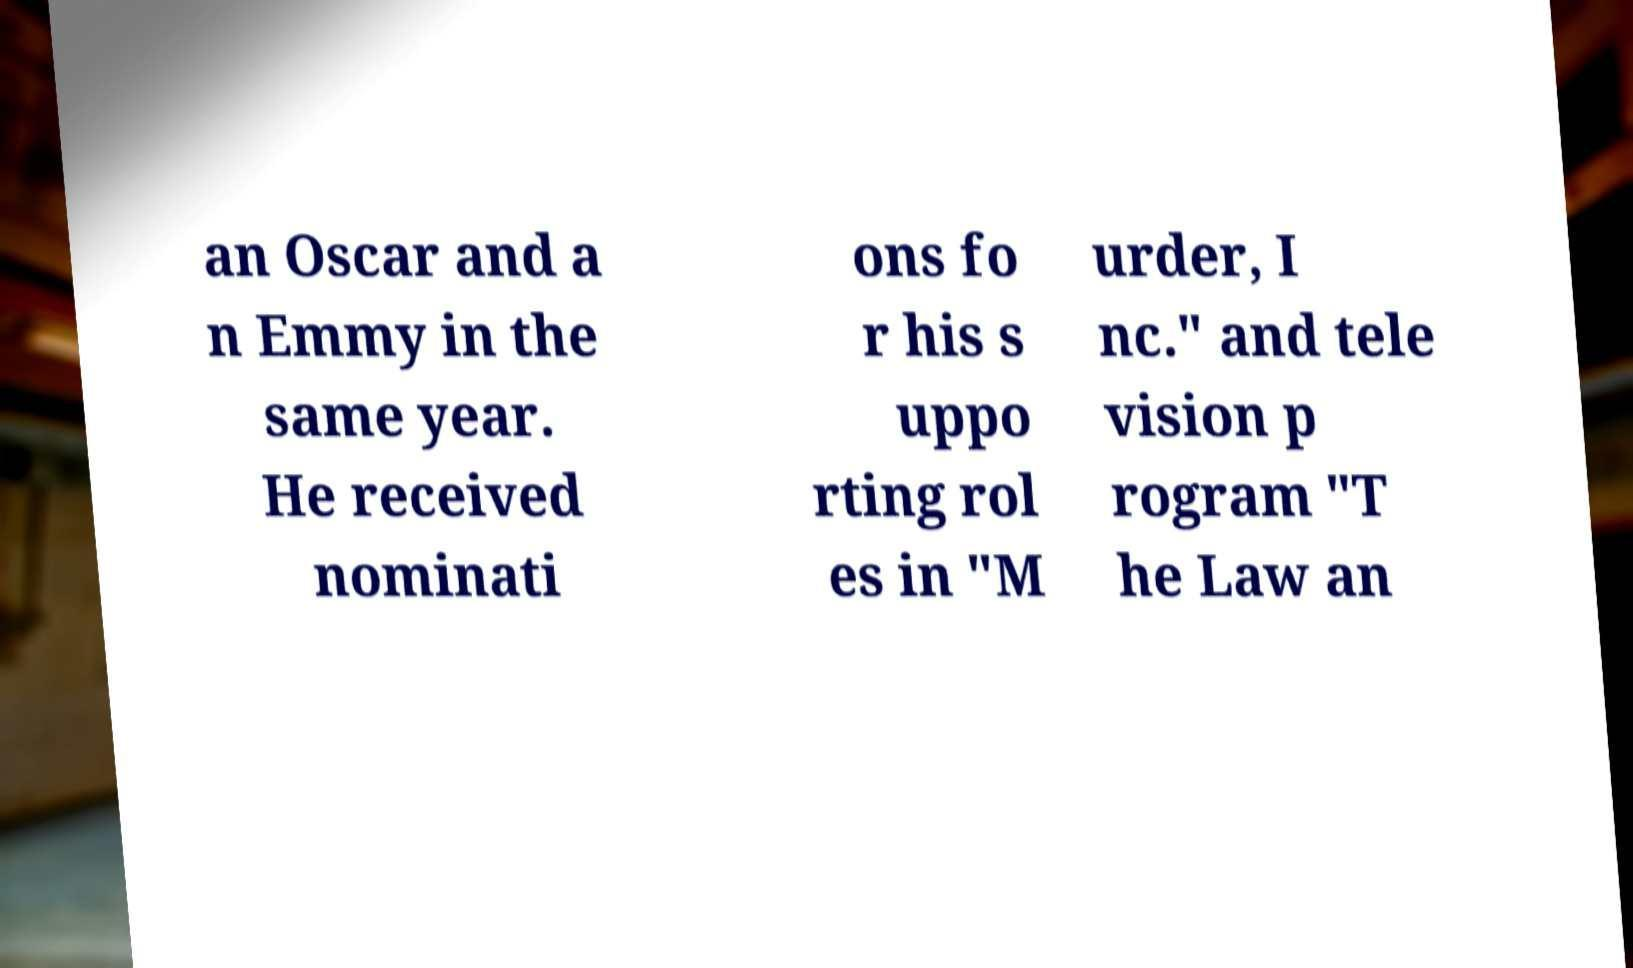I need the written content from this picture converted into text. Can you do that? an Oscar and a n Emmy in the same year. He received nominati ons fo r his s uppo rting rol es in "M urder, I nc." and tele vision p rogram "T he Law an 